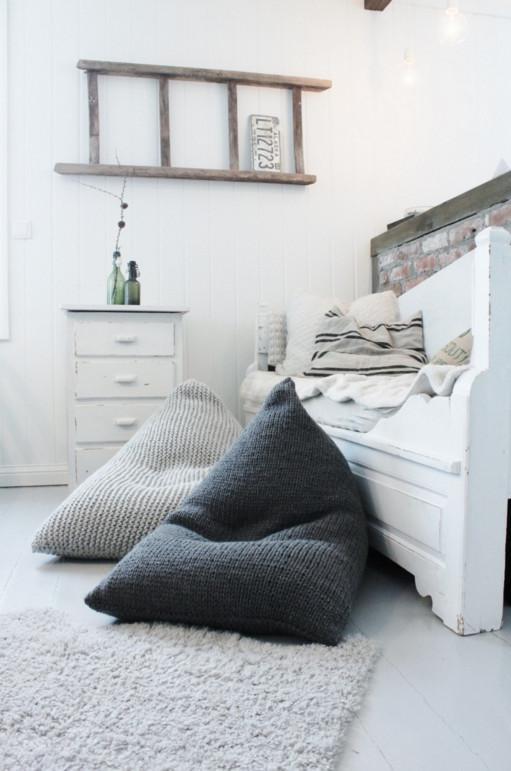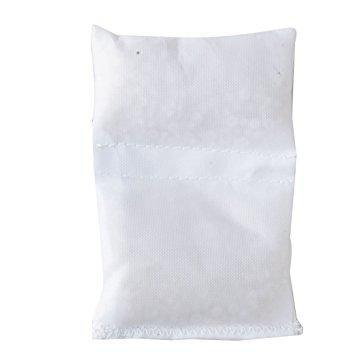The first image is the image on the left, the second image is the image on the right. Examine the images to the left and right. Is the description "At least one of the cushions is knitted." accurate? Answer yes or no. Yes. The first image is the image on the left, the second image is the image on the right. Assess this claim about the two images: "The pillow is in front of a bench". Correct or not? Answer yes or no. Yes. 